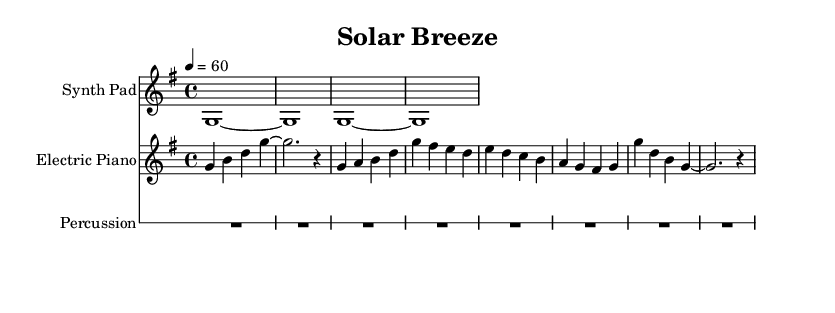What is the key signature of this music? The key signature is G major, which has one sharp (F#). This is indicated at the beginning of the staff where the sharp is placed on the F line.
Answer: G major What is the time signature of this music? The time signature is 4/4, which is indicated at the beginning of the score. It shows that there are four beats in a measure and that a quarter note receives one beat.
Answer: 4/4 What is the tempo marking for this piece? The tempo marking indicates a speed of 60 beats per minute, noted in the score as "4 = 60". This means that quarter notes are played at this rate.
Answer: 60 How many measures does the Synth Pad part have? The Synth Pad part consists of 4 measures, as indicated by the four blocks of music between the bar lines. Counting each group gives the total.
Answer: 4 Which instruments are used in this piece? The instruments include a Synth Pad, Electric Piano, and Percussion. Each has its own staff clearly labeled at the beginning of their respective sections.
Answer: Synth Pad, Electric Piano, and Percussion What is the rhythmic pattern used in the percussion staff? The percussion staff contains a rest for the entire duration indicated (R1*8), which means there are no notes played in that section.
Answer: Rest What is the first note played by the Electric Piano? The first note played by the Electric Piano is G, as seen in the first measure where the notes are G, B, D, and G.
Answer: G 